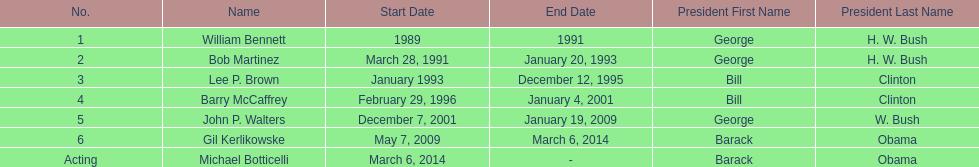Who was the next appointed director after lee p. brown? Barry McCaffrey. 